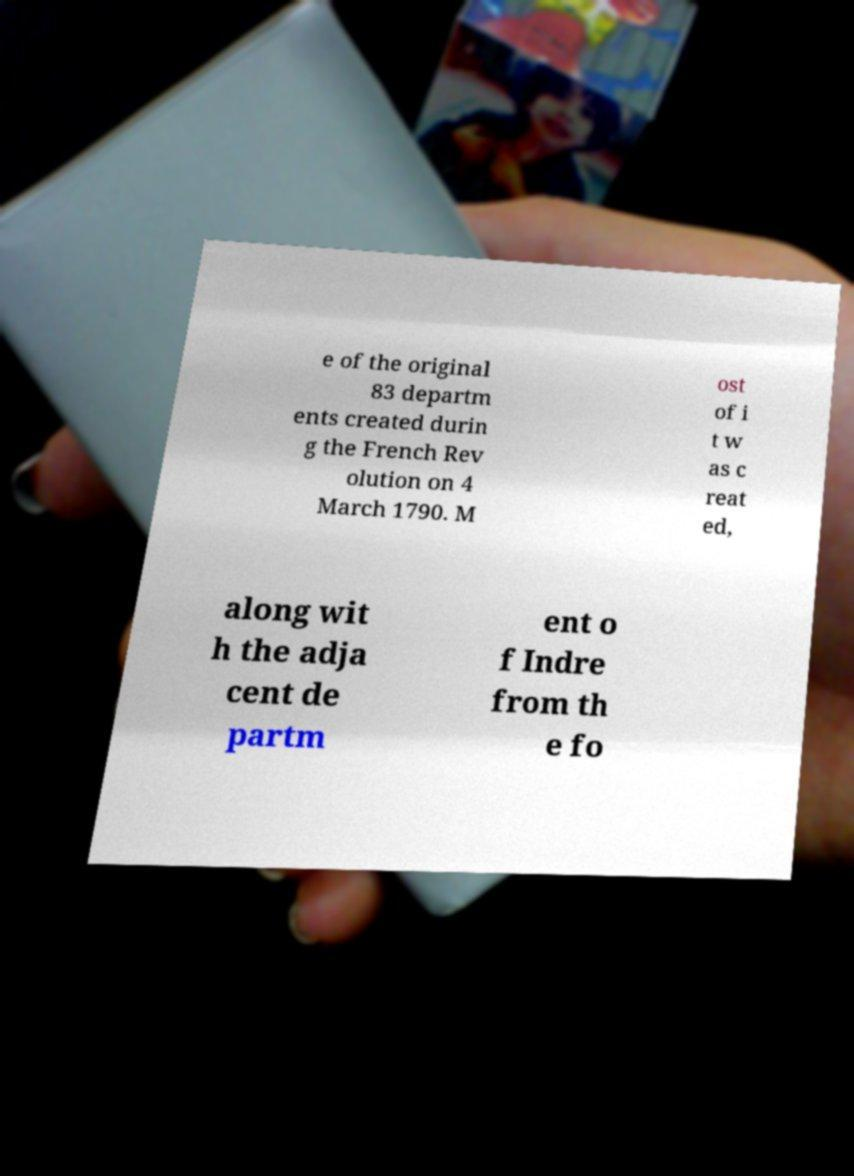Could you extract and type out the text from this image? e of the original 83 departm ents created durin g the French Rev olution on 4 March 1790. M ost of i t w as c reat ed, along wit h the adja cent de partm ent o f Indre from th e fo 